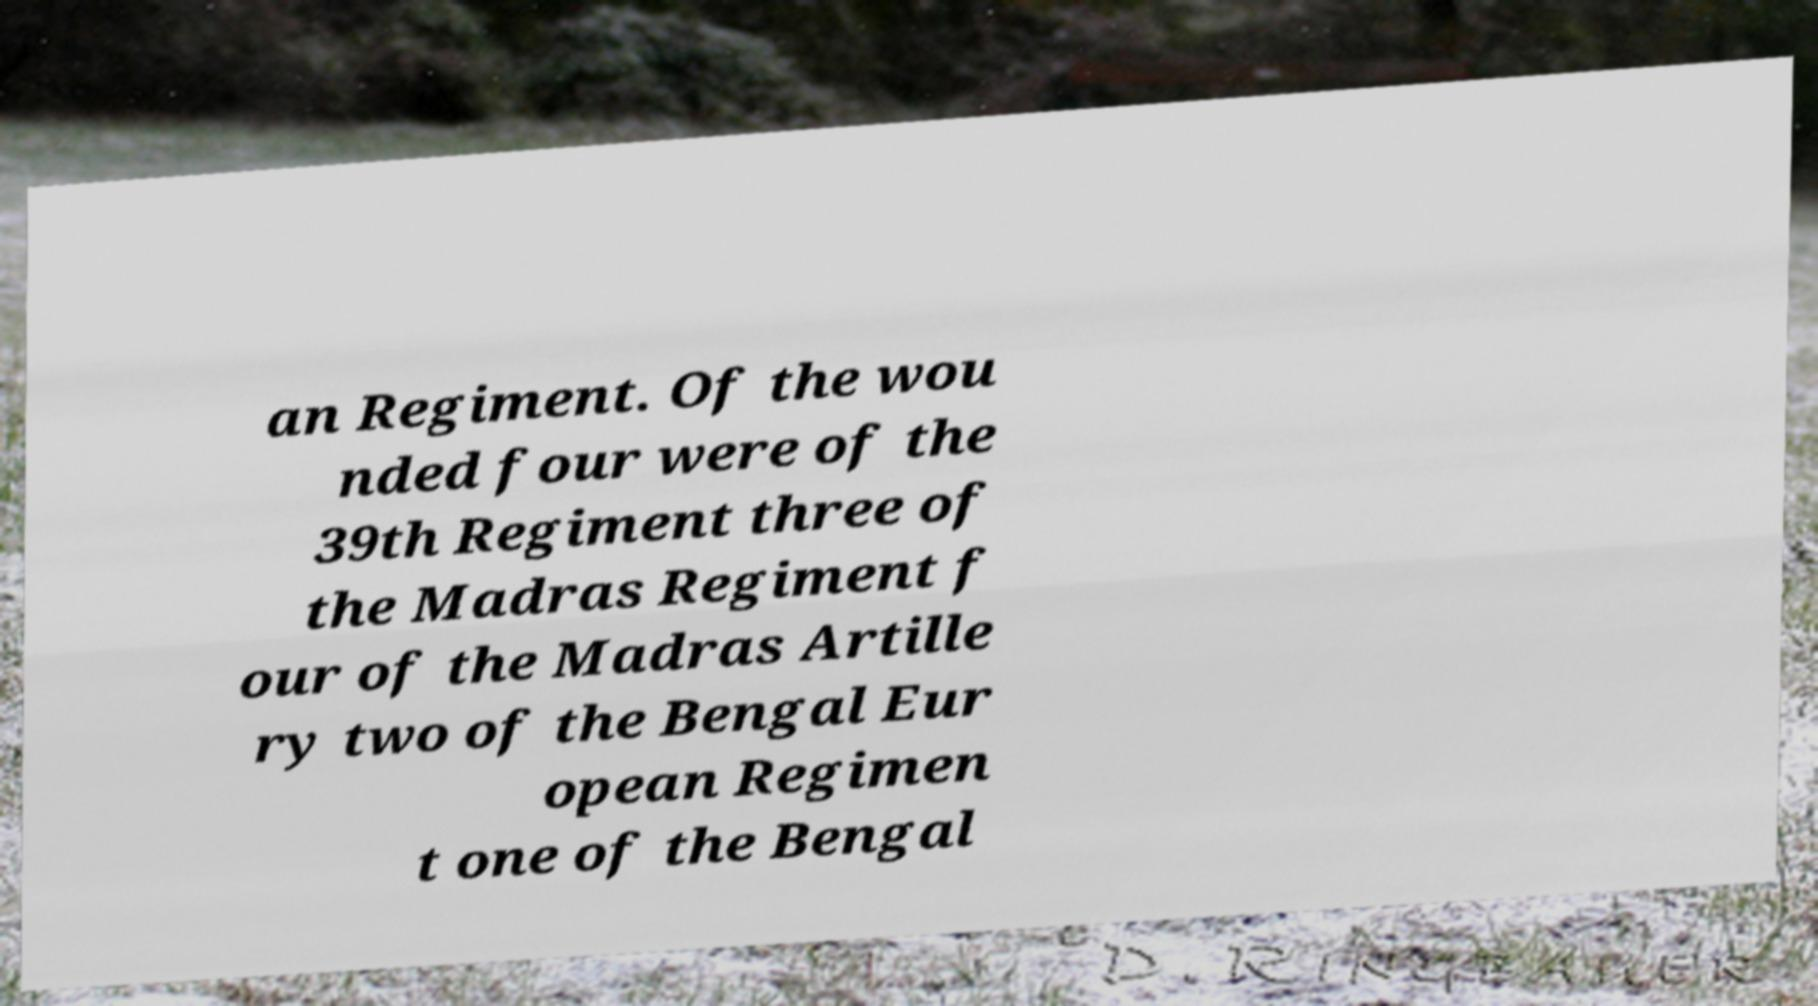Can you read and provide the text displayed in the image?This photo seems to have some interesting text. Can you extract and type it out for me? an Regiment. Of the wou nded four were of the 39th Regiment three of the Madras Regiment f our of the Madras Artille ry two of the Bengal Eur opean Regimen t one of the Bengal 